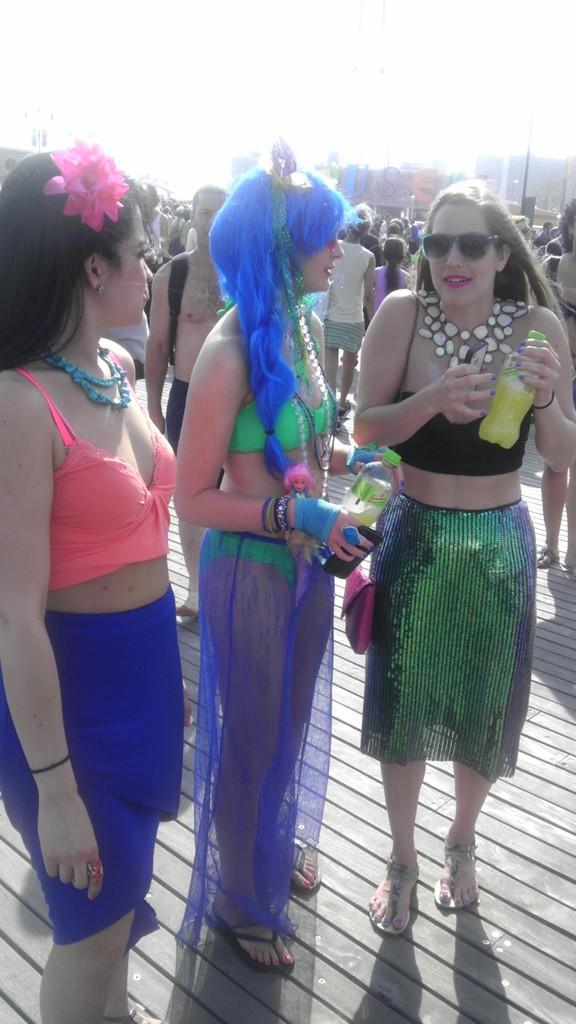How many people are in the image? There is a group of people in the image. What are the people doing in the image? The people are standing on the floor. What are two of the people holding? Two of the people are holding bottles. What can be seen in the background of the image? There are buildings and the sky visible in the background of the image. What type of corn is being harvested by the people in the image? There is no corn present in the image; the people are standing on the floor and holding bottles. How many hands are visible in the image? The number of hands visible in the image cannot be determined without counting each individual hand, which is not necessary to answer the questions based on the provided facts. 